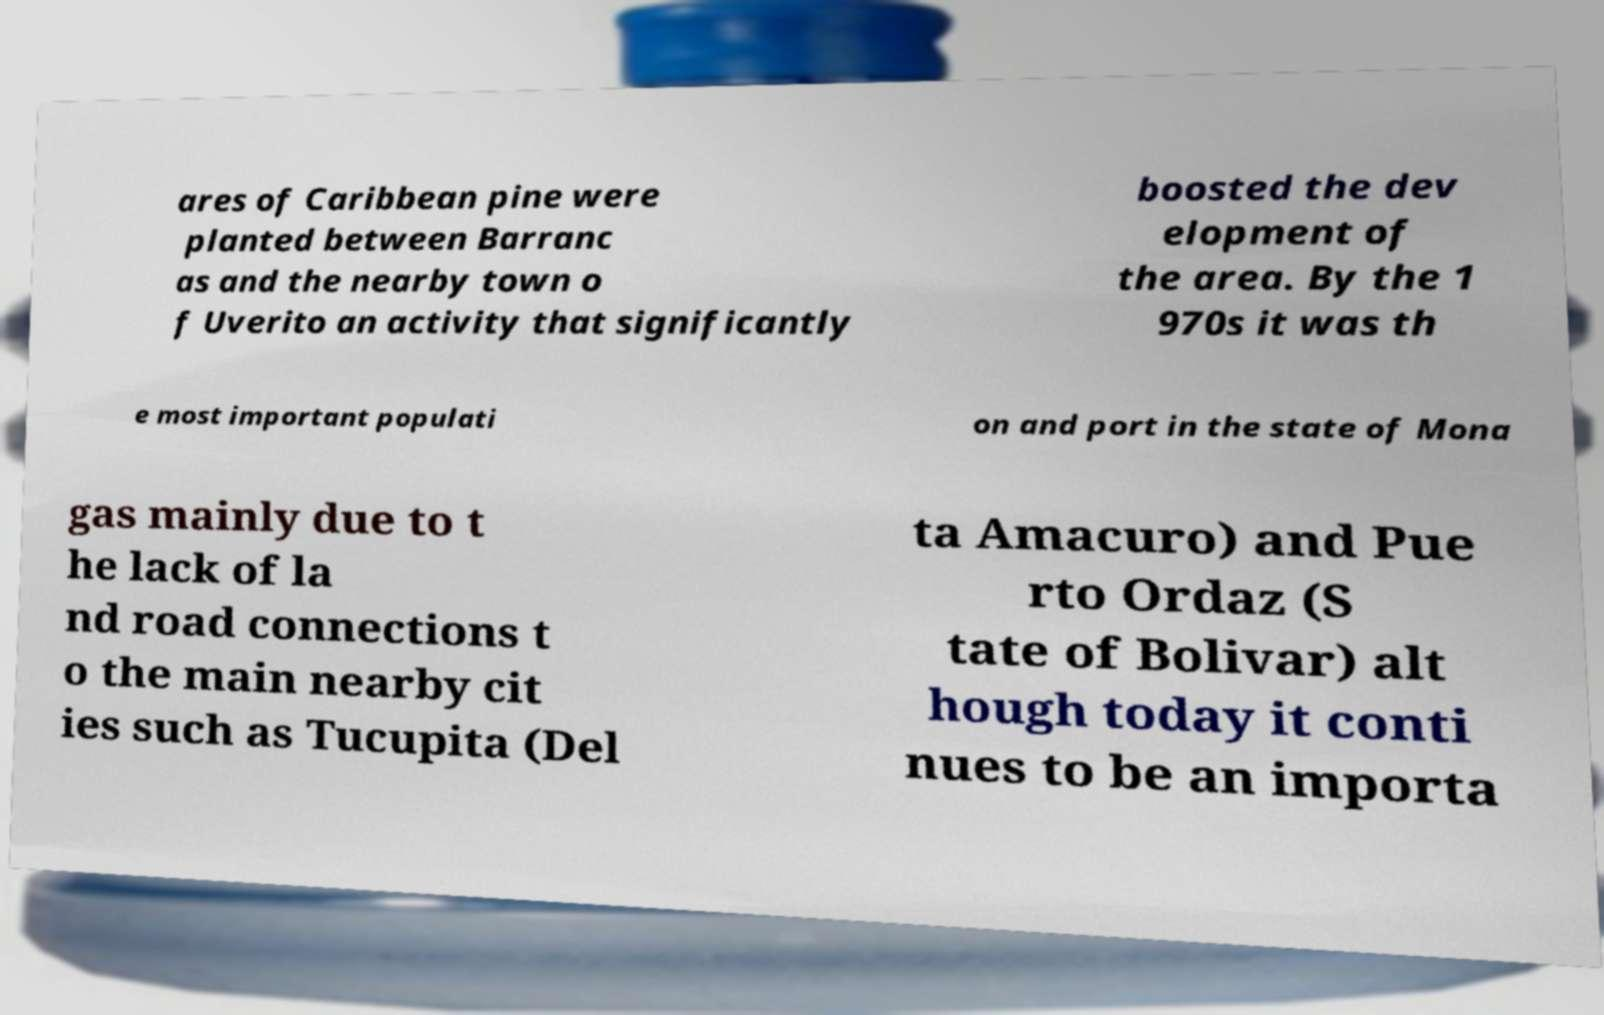Can you read and provide the text displayed in the image?This photo seems to have some interesting text. Can you extract and type it out for me? ares of Caribbean pine were planted between Barranc as and the nearby town o f Uverito an activity that significantly boosted the dev elopment of the area. By the 1 970s it was th e most important populati on and port in the state of Mona gas mainly due to t he lack of la nd road connections t o the main nearby cit ies such as Tucupita (Del ta Amacuro) and Pue rto Ordaz (S tate of Bolivar) alt hough today it conti nues to be an importa 